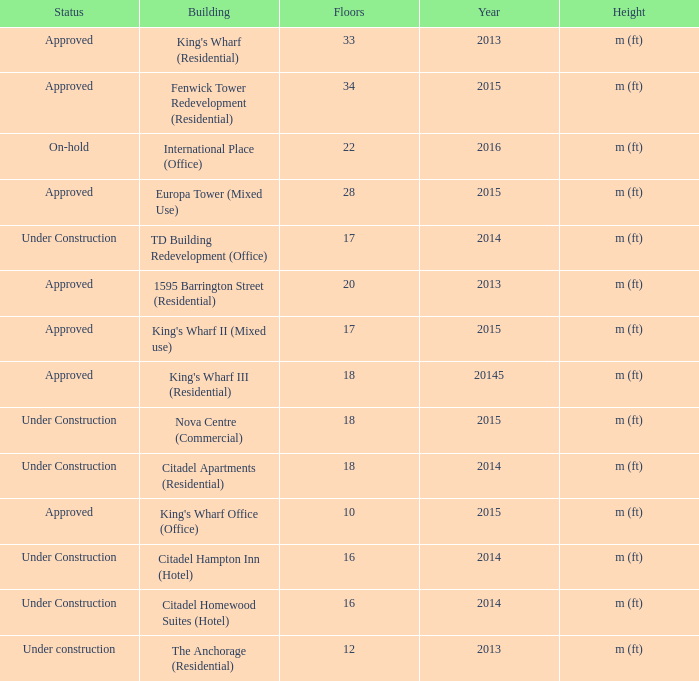What is the status of the building with less than 18 floors and later than 2013? Under Construction, Approved, Approved, Under Construction, Under Construction. 